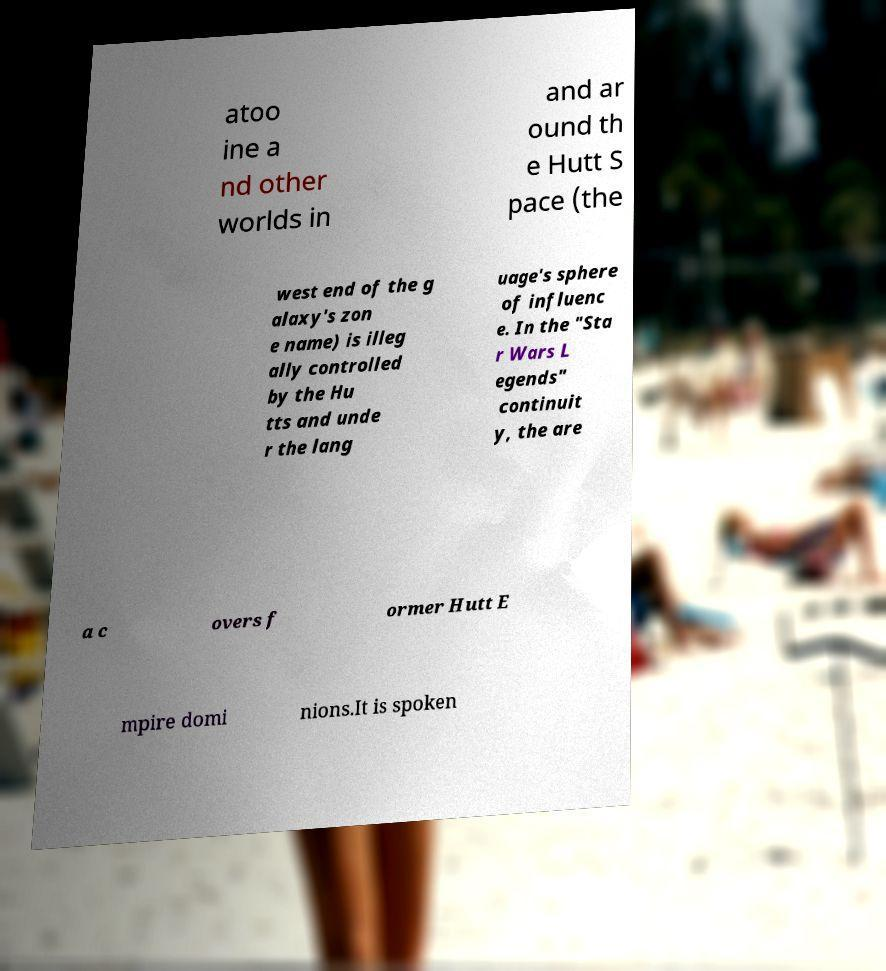Please identify and transcribe the text found in this image. atoo ine a nd other worlds in and ar ound th e Hutt S pace (the west end of the g alaxy's zon e name) is illeg ally controlled by the Hu tts and unde r the lang uage's sphere of influenc e. In the "Sta r Wars L egends" continuit y, the are a c overs f ormer Hutt E mpire domi nions.It is spoken 